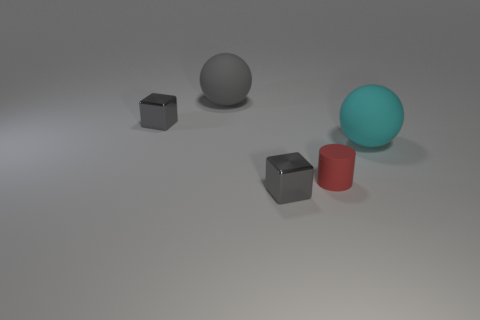What number of purple objects are matte objects or large rubber things?
Provide a succinct answer. 0. How many rubber things are to the left of the large cyan matte ball and behind the tiny red matte cylinder?
Offer a terse response. 1. Is the material of the cyan ball the same as the red object?
Your answer should be compact. Yes. What is the shape of the gray object that is the same size as the cyan matte ball?
Give a very brief answer. Sphere. Are there more green metallic things than spheres?
Ensure brevity in your answer.  No. There is a object that is both to the left of the red matte thing and on the right side of the large gray matte ball; what material is it?
Offer a terse response. Metal. How many other objects are the same material as the large cyan ball?
Your response must be concise. 2. What number of other objects are the same color as the small rubber object?
Your answer should be very brief. 0. There is a gray metallic object that is behind the gray object that is in front of the large sphere in front of the big gray matte ball; how big is it?
Your answer should be very brief. Small. How many shiny objects are brown things or small cubes?
Ensure brevity in your answer.  2. 